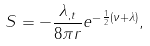Convert formula to latex. <formula><loc_0><loc_0><loc_500><loc_500>S = - \frac { \lambda _ { , t } } { 8 \pi r } e ^ { - \frac { 1 } { 2 } ( \nu + \lambda ) } ,</formula> 